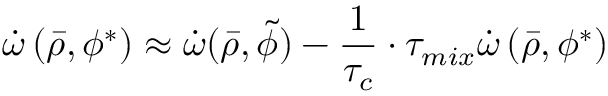<formula> <loc_0><loc_0><loc_500><loc_500>\dot { \omega } \left ( \bar { \rho } , \phi ^ { * } \right ) \approx \dot { \omega } ( \bar { \rho } , \widetilde { \phi } ) - \frac { 1 } { \tau _ { c } } \cdot \tau _ { m i x } \dot { \omega } \left ( \bar { \rho } , \phi ^ { * } \right )</formula> 